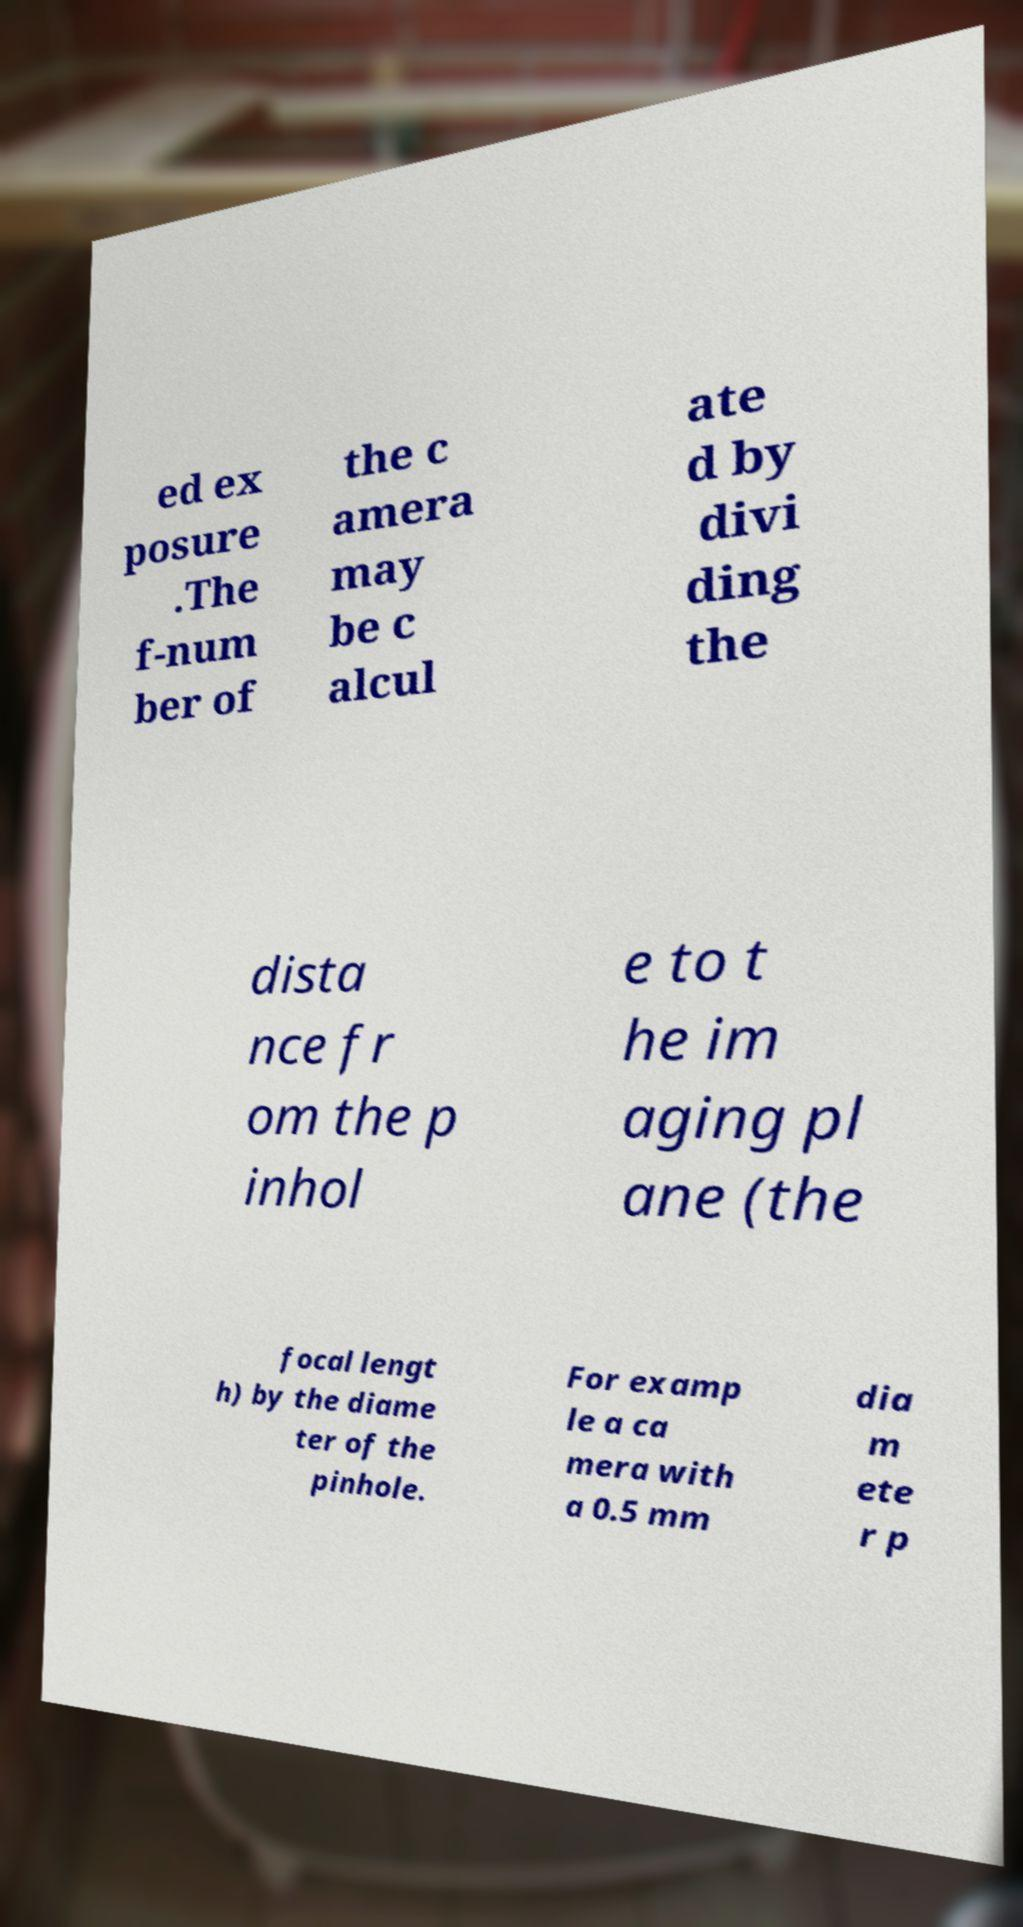Please read and relay the text visible in this image. What does it say? ed ex posure .The f-num ber of the c amera may be c alcul ate d by divi ding the dista nce fr om the p inhol e to t he im aging pl ane (the focal lengt h) by the diame ter of the pinhole. For examp le a ca mera with a 0.5 mm dia m ete r p 